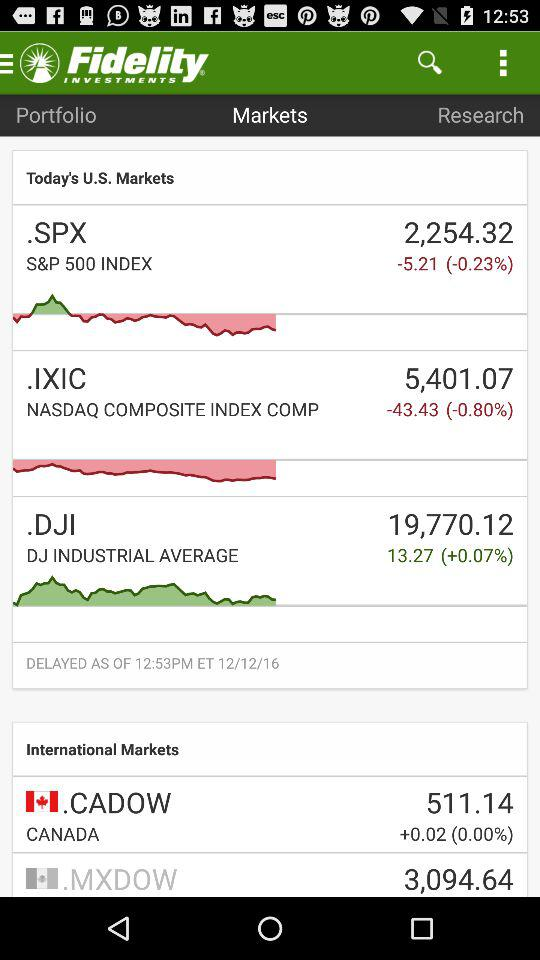What is the change in percentage terms for the S&P 500 index?
Answer the question using a single word or phrase. -0.23% 